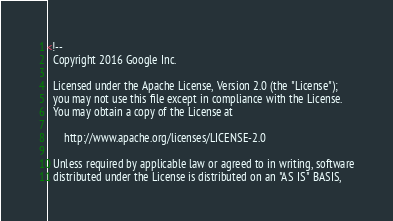Convert code to text. <code><loc_0><loc_0><loc_500><loc_500><_XML_><!--
  Copyright 2016 Google Inc.

  Licensed under the Apache License, Version 2.0 (the "License");
  you may not use this file except in compliance with the License.
  You may obtain a copy of the License at

      http://www.apache.org/licenses/LICENSE-2.0

  Unless required by applicable law or agreed to in writing, software
  distributed under the License is distributed on an "AS IS" BASIS,</code> 